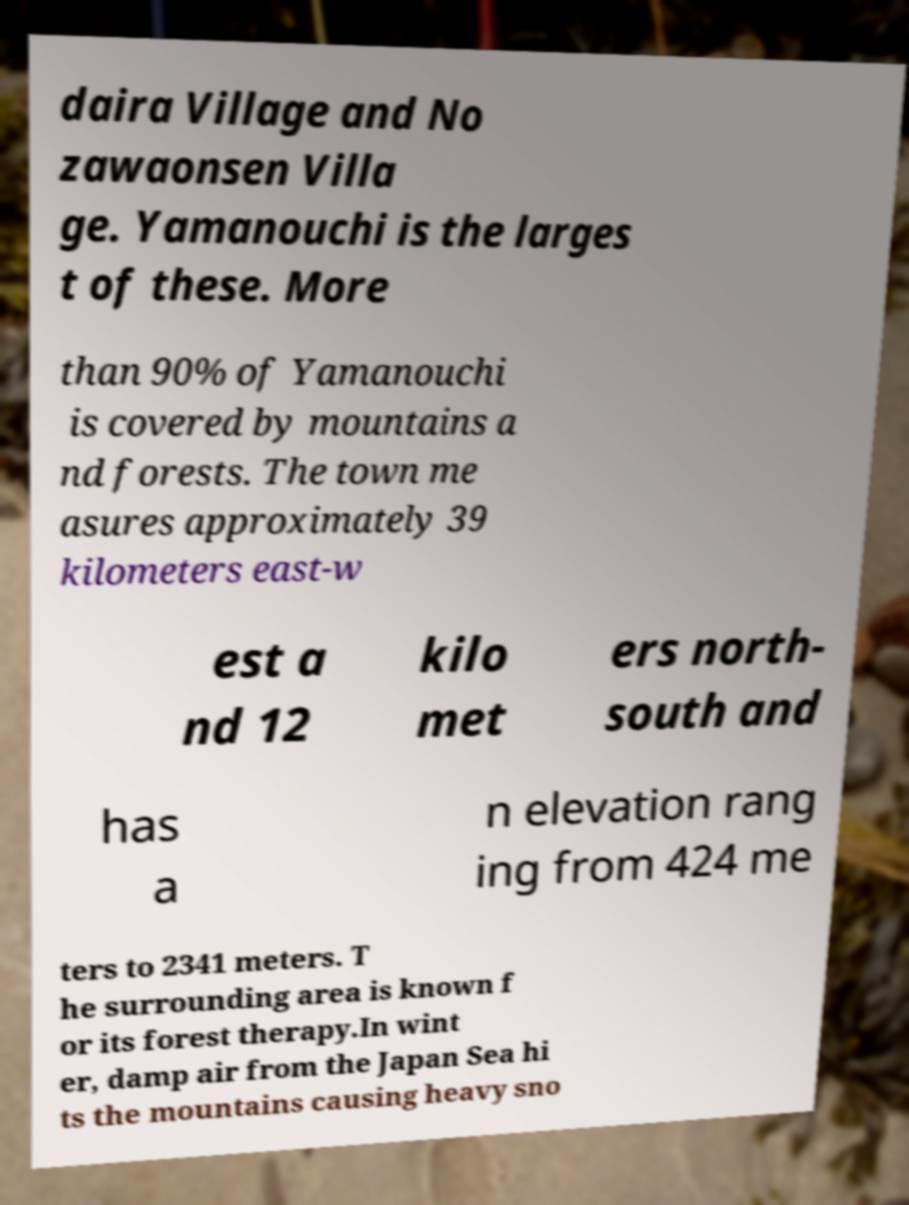Please read and relay the text visible in this image. What does it say? daira Village and No zawaonsen Villa ge. Yamanouchi is the larges t of these. More than 90% of Yamanouchi is covered by mountains a nd forests. The town me asures approximately 39 kilometers east-w est a nd 12 kilo met ers north- south and has a n elevation rang ing from 424 me ters to 2341 meters. T he surrounding area is known f or its forest therapy.In wint er, damp air from the Japan Sea hi ts the mountains causing heavy sno 